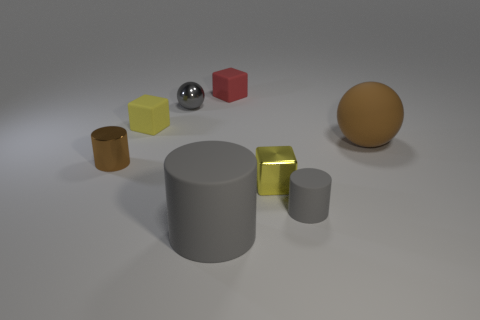There is a brown thing to the right of the tiny yellow matte object; how big is it?
Make the answer very short. Large. What is the shape of the tiny thing that is the same color as the small metal sphere?
Your answer should be compact. Cylinder. What shape is the brown thing that is on the left side of the large matte thing behind the brown thing that is to the left of the brown matte sphere?
Provide a short and direct response. Cylinder. How many other things are there of the same shape as the small brown thing?
Your answer should be very brief. 2. What number of metal objects are small blue blocks or large brown objects?
Your answer should be compact. 0. What material is the tiny cylinder to the left of the tiny yellow block behind the shiny cylinder?
Ensure brevity in your answer.  Metal. Are there more yellow objects on the right side of the small red cube than big green matte objects?
Your answer should be compact. Yes. Is there a small cube that has the same material as the tiny brown thing?
Make the answer very short. Yes. Do the small matte object that is on the right side of the small yellow metallic block and the big brown object have the same shape?
Ensure brevity in your answer.  No. How many red rubber blocks are in front of the small yellow thing that is in front of the tiny brown cylinder that is left of the large brown rubber ball?
Your answer should be very brief. 0. 